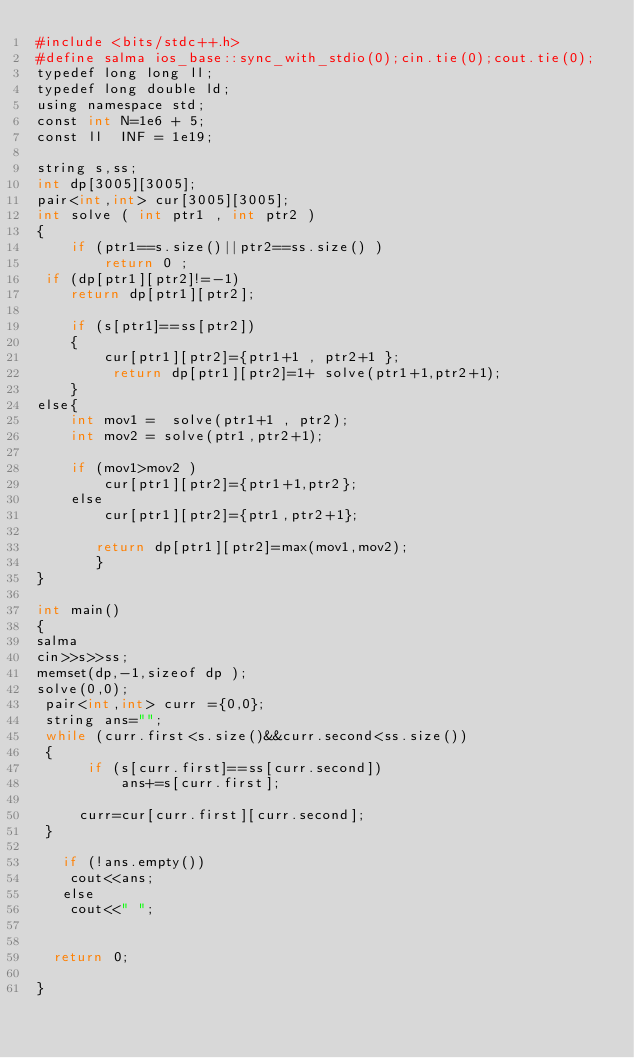Convert code to text. <code><loc_0><loc_0><loc_500><loc_500><_Awk_>#include <bits/stdc++.h>
#define salma ios_base::sync_with_stdio(0);cin.tie(0);cout.tie(0);
typedef long long ll;
typedef long double ld;
using namespace std;
const int N=1e6 + 5;
const ll  INF = 1e19;

string s,ss;
int dp[3005][3005];
pair<int,int> cur[3005][3005];
int solve ( int ptr1 , int ptr2 )
{
    if (ptr1==s.size()||ptr2==ss.size() )
        return 0 ;
 if (dp[ptr1][ptr2]!=-1)
    return dp[ptr1][ptr2];

    if (s[ptr1]==ss[ptr2])
    {
        cur[ptr1][ptr2]={ptr1+1 , ptr2+1 };
         return dp[ptr1][ptr2]=1+ solve(ptr1+1,ptr2+1);
    }
else{
    int mov1 =  solve(ptr1+1 , ptr2);
    int mov2 = solve(ptr1,ptr2+1);

    if (mov1>mov2 )
        cur[ptr1][ptr2]={ptr1+1,ptr2};
    else
        cur[ptr1][ptr2]={ptr1,ptr2+1};

       return dp[ptr1][ptr2]=max(mov1,mov2);
       }
}

int main()
{
salma
cin>>s>>ss;
memset(dp,-1,sizeof dp );
solve(0,0);
 pair<int,int> curr ={0,0};
 string ans="";
 while (curr.first<s.size()&&curr.second<ss.size())
 {
      if (s[curr.first]==ss[curr.second])
          ans+=s[curr.first];

     curr=cur[curr.first][curr.second];
 }

   if (!ans.empty())
    cout<<ans;
   else
    cout<<" ";


  return 0;

}
</code> 